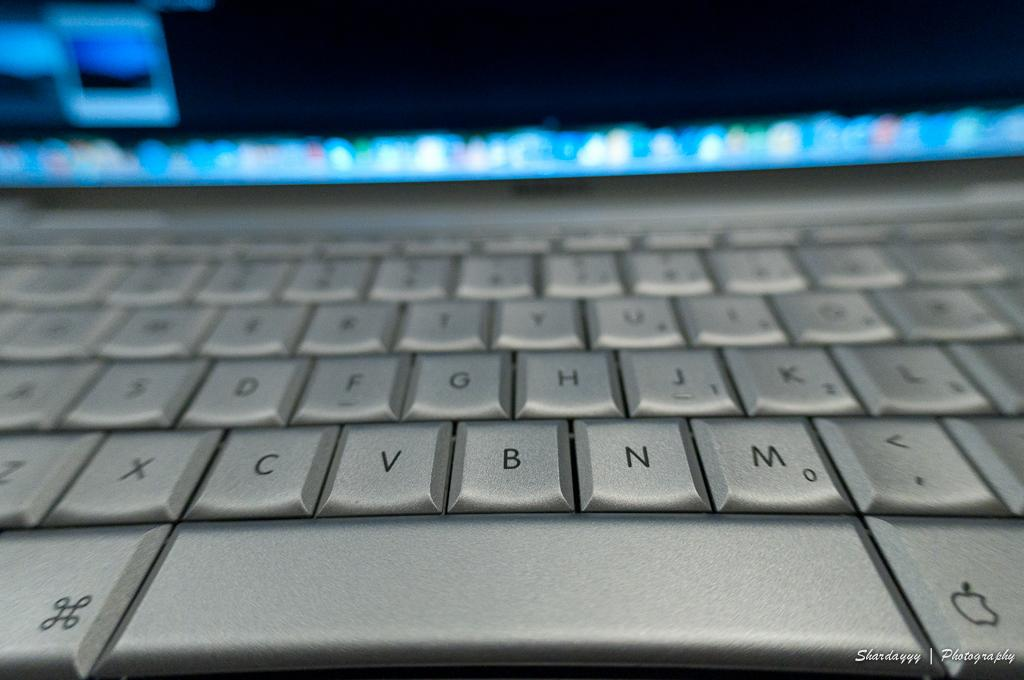Provide a one-sentence caption for the provided image. a silver key board with letters such as C, V and B. 